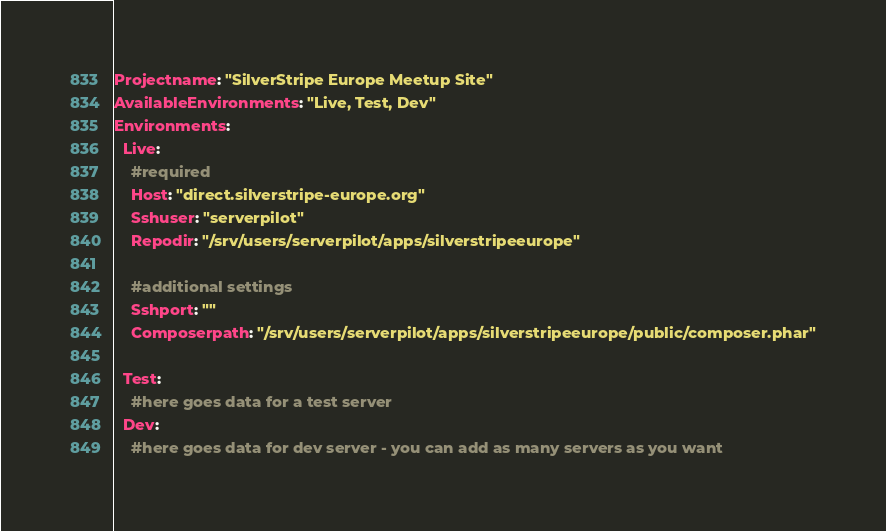<code> <loc_0><loc_0><loc_500><loc_500><_YAML_>Projectname: "SilverStripe Europe Meetup Site"
AvailableEnvironments: "Live, Test, Dev"
Environments:
  Live:
    #required
    Host: "direct.silverstripe-europe.org"
    Sshuser: "serverpilot"
    Repodir: "/srv/users/serverpilot/apps/silverstripeeurope"

    #additional settings
    Sshport: ""
    Composerpath: "/srv/users/serverpilot/apps/silverstripeeurope/public/composer.phar"

  Test:
    #here goes data for a test server
  Dev:
    #here goes data for dev server - you can add as many servers as you want


</code> 